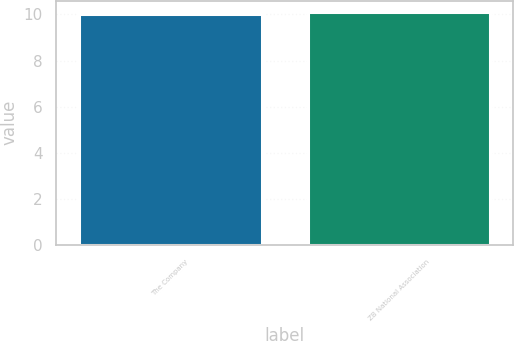<chart> <loc_0><loc_0><loc_500><loc_500><bar_chart><fcel>The Company<fcel>ZB National Association<nl><fcel>10<fcel>10.1<nl></chart> 